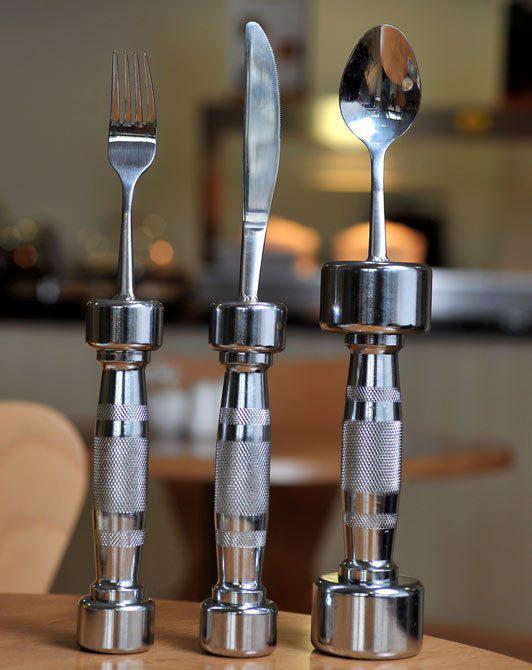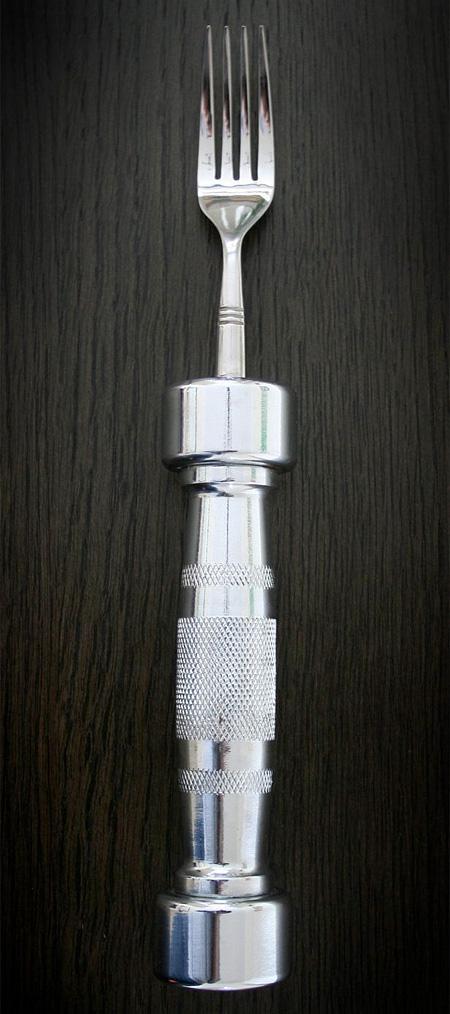The first image is the image on the left, the second image is the image on the right. Considering the images on both sides, is "There is a knife, fork, and spoon in the image on the right." valid? Answer yes or no. No. 